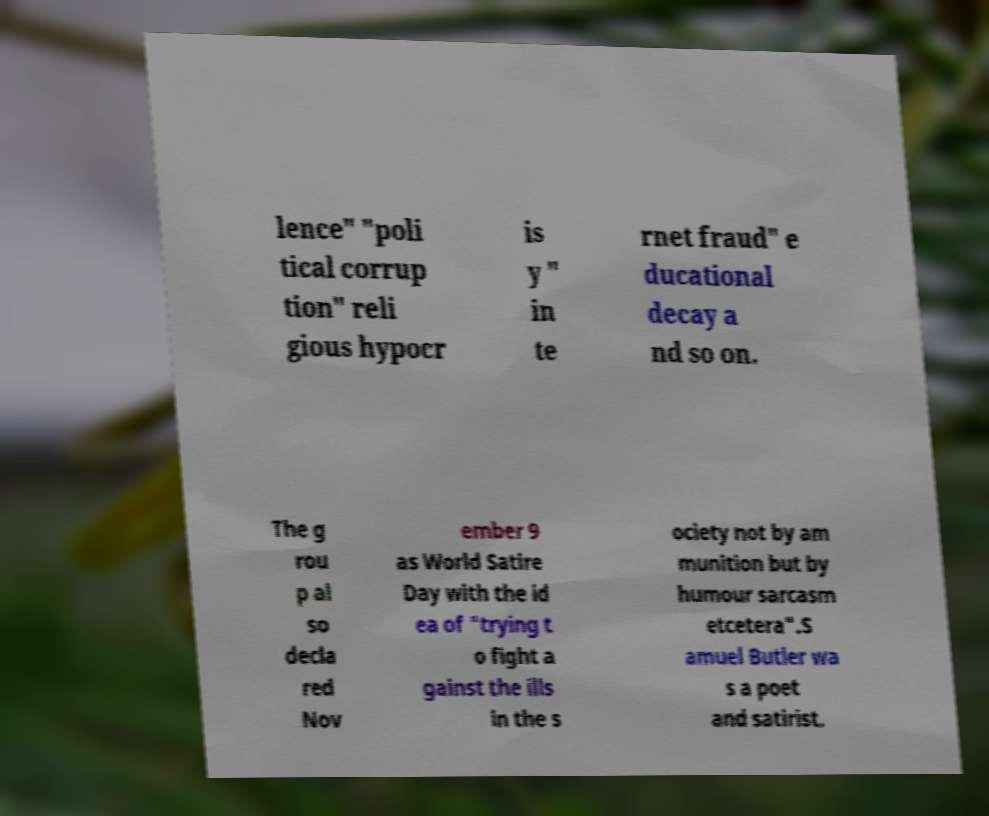Can you accurately transcribe the text from the provided image for me? lence" "poli tical corrup tion" reli gious hypocr is y " in te rnet fraud" e ducational decay a nd so on. The g rou p al so decla red Nov ember 9 as World Satire Day with the id ea of "trying t o fight a gainst the ills in the s ociety not by am munition but by humour sarcasm etcetera".S amuel Butler wa s a poet and satirist. 